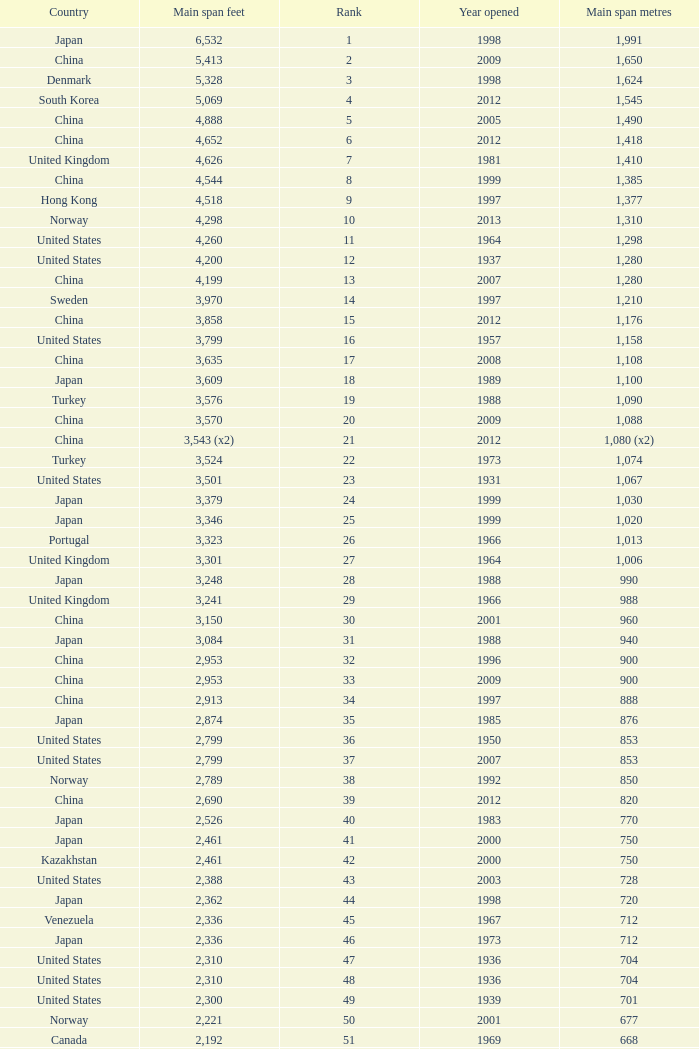What is the main span in feet from a year of 2009 or more recent with a rank less than 94 and 1,310 main span metres? 4298.0. 